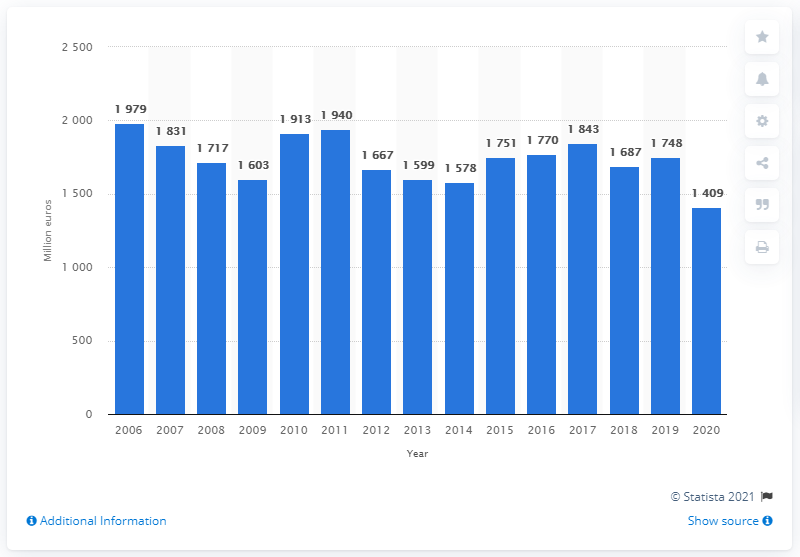Highlight a few significant elements in this photo. The net sales of the Reebok brand in 2020 were $1,409 million. 